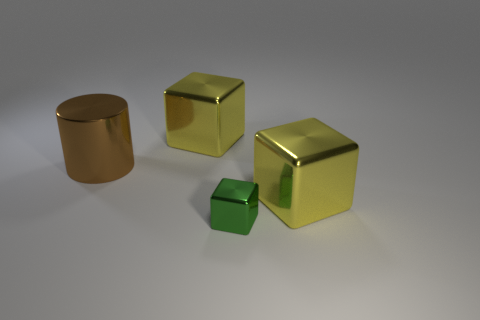Add 1 big yellow cubes. How many objects exist? 5 Subtract all cubes. How many objects are left? 1 Add 1 large metal cylinders. How many large metal cylinders are left? 2 Add 3 small green things. How many small green things exist? 4 Subtract 0 blue cubes. How many objects are left? 4 Subtract all small green matte balls. Subtract all yellow metal cubes. How many objects are left? 2 